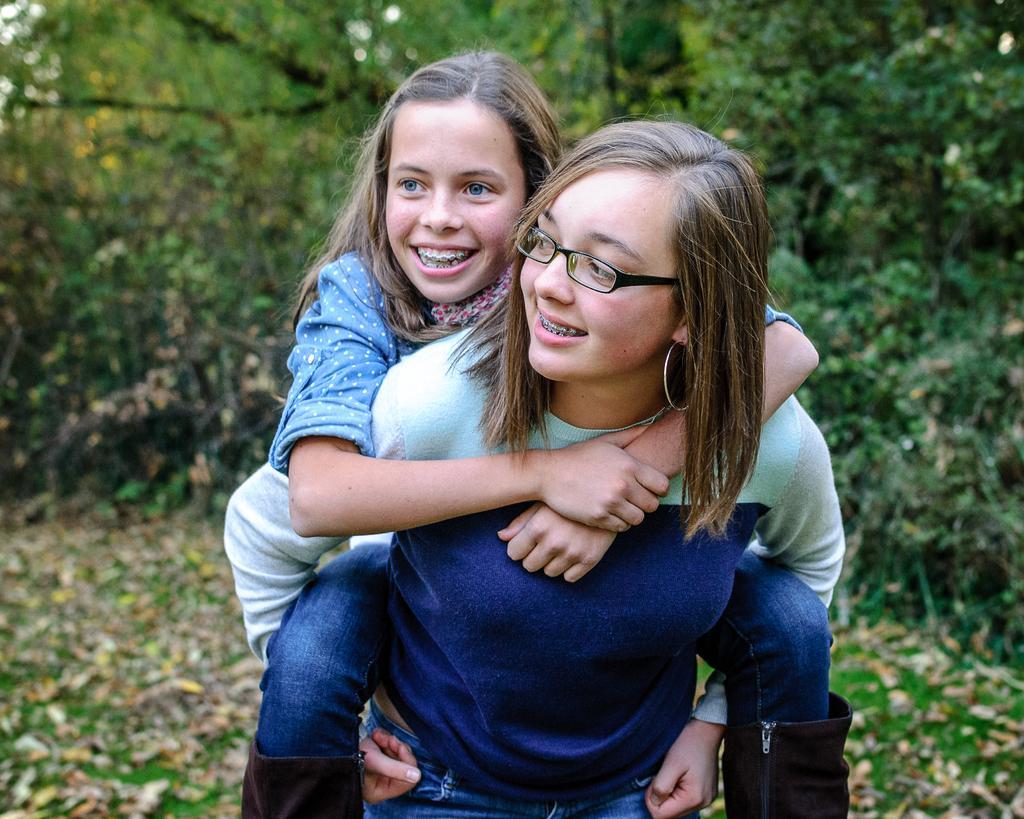In one or two sentences, can you explain what this image depicts? In the front of the image I can see two people are smiling. In the background of the image it is blurry and there are trees. 